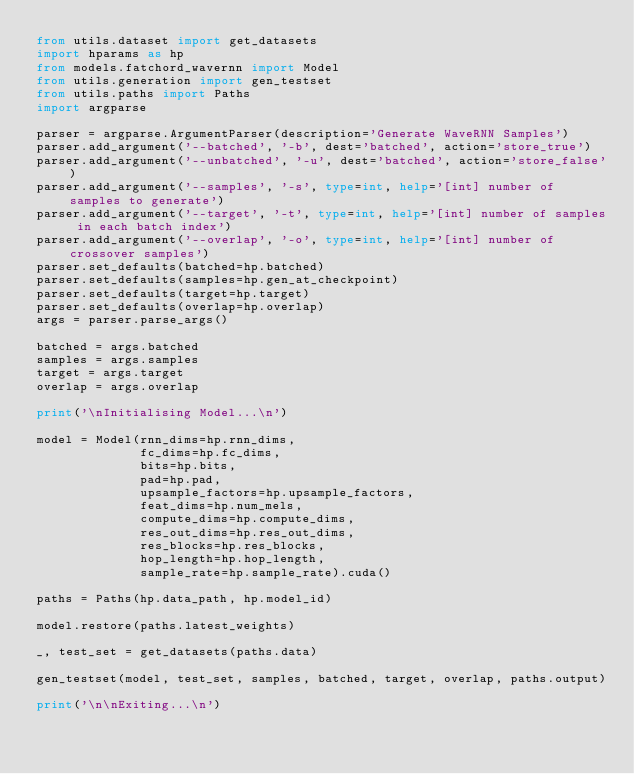Convert code to text. <code><loc_0><loc_0><loc_500><loc_500><_Python_>from utils.dataset import get_datasets
import hparams as hp
from models.fatchord_wavernn import Model
from utils.generation import gen_testset
from utils.paths import Paths
import argparse

parser = argparse.ArgumentParser(description='Generate WaveRNN Samples')
parser.add_argument('--batched', '-b', dest='batched', action='store_true')
parser.add_argument('--unbatched', '-u', dest='batched', action='store_false')
parser.add_argument('--samples', '-s', type=int, help='[int] number of samples to generate')
parser.add_argument('--target', '-t', type=int, help='[int] number of samples in each batch index')
parser.add_argument('--overlap', '-o', type=int, help='[int] number of crossover samples')
parser.set_defaults(batched=hp.batched)
parser.set_defaults(samples=hp.gen_at_checkpoint)
parser.set_defaults(target=hp.target)
parser.set_defaults(overlap=hp.overlap)
args = parser.parse_args()

batched = args.batched
samples = args.samples
target = args.target
overlap = args.overlap

print('\nInitialising Model...\n')

model = Model(rnn_dims=hp.rnn_dims,
              fc_dims=hp.fc_dims,
              bits=hp.bits,
              pad=hp.pad,
              upsample_factors=hp.upsample_factors,
              feat_dims=hp.num_mels,
              compute_dims=hp.compute_dims,
              res_out_dims=hp.res_out_dims,
              res_blocks=hp.res_blocks,
              hop_length=hp.hop_length,
              sample_rate=hp.sample_rate).cuda()

paths = Paths(hp.data_path, hp.model_id)

model.restore(paths.latest_weights)

_, test_set = get_datasets(paths.data)

gen_testset(model, test_set, samples, batched, target, overlap, paths.output)

print('\n\nExiting...\n')
</code> 